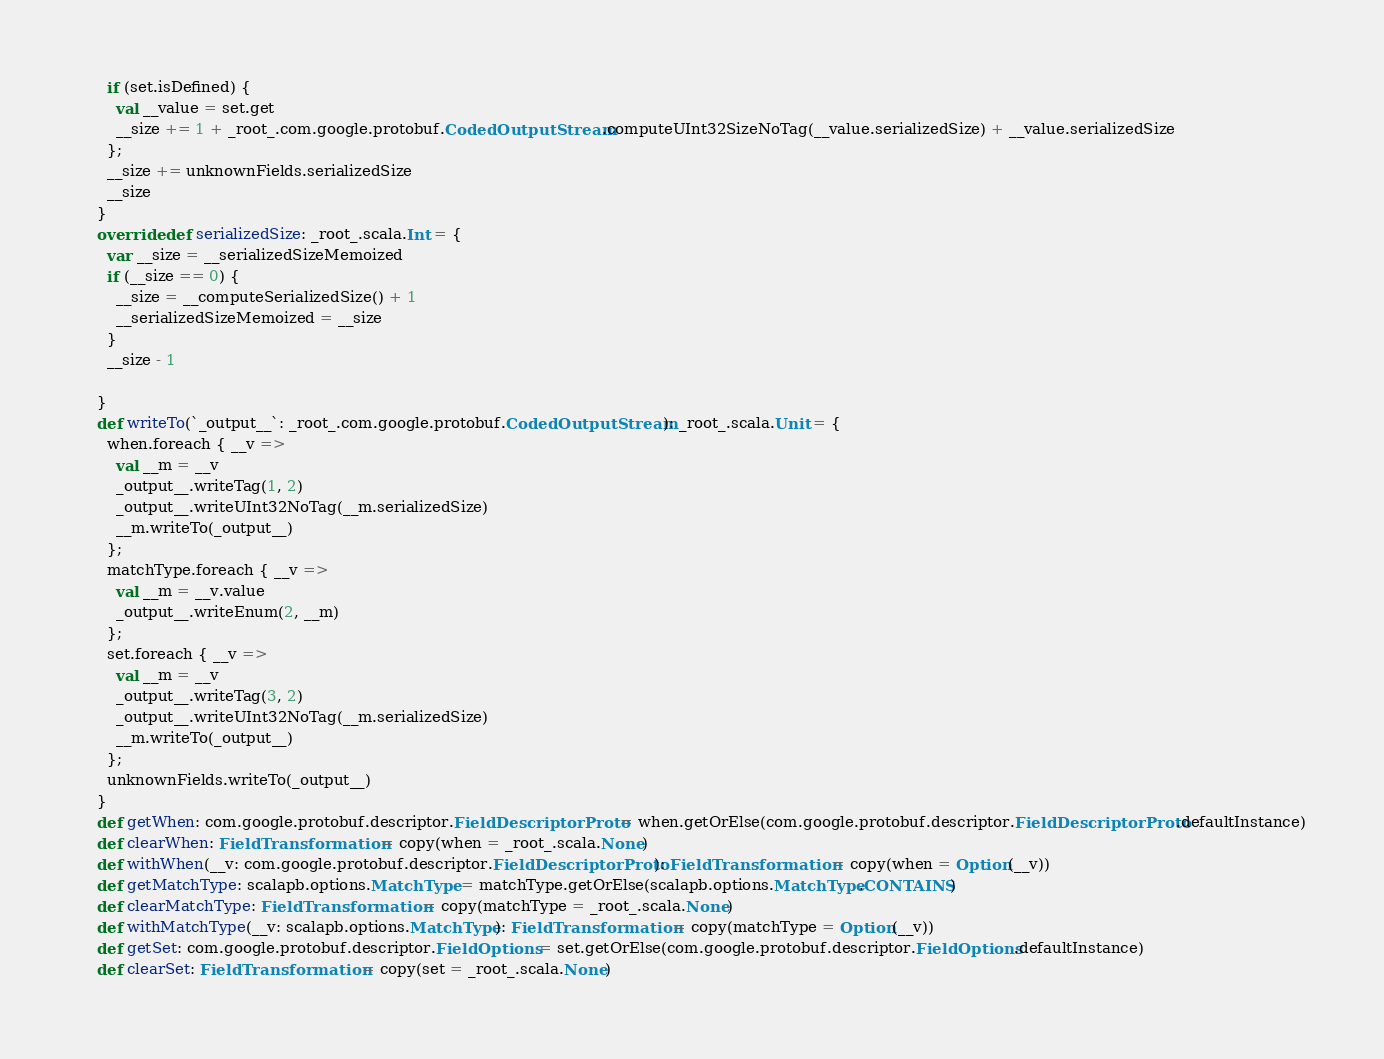Convert code to text. <code><loc_0><loc_0><loc_500><loc_500><_Scala_>      if (set.isDefined) {
        val __value = set.get
        __size += 1 + _root_.com.google.protobuf.CodedOutputStream.computeUInt32SizeNoTag(__value.serializedSize) + __value.serializedSize
      };
      __size += unknownFields.serializedSize
      __size
    }
    override def serializedSize: _root_.scala.Int = {
      var __size = __serializedSizeMemoized
      if (__size == 0) {
        __size = __computeSerializedSize() + 1
        __serializedSizeMemoized = __size
      }
      __size - 1
      
    }
    def writeTo(`_output__`: _root_.com.google.protobuf.CodedOutputStream): _root_.scala.Unit = {
      when.foreach { __v =>
        val __m = __v
        _output__.writeTag(1, 2)
        _output__.writeUInt32NoTag(__m.serializedSize)
        __m.writeTo(_output__)
      };
      matchType.foreach { __v =>
        val __m = __v.value
        _output__.writeEnum(2, __m)
      };
      set.foreach { __v =>
        val __m = __v
        _output__.writeTag(3, 2)
        _output__.writeUInt32NoTag(__m.serializedSize)
        __m.writeTo(_output__)
      };
      unknownFields.writeTo(_output__)
    }
    def getWhen: com.google.protobuf.descriptor.FieldDescriptorProto = when.getOrElse(com.google.protobuf.descriptor.FieldDescriptorProto.defaultInstance)
    def clearWhen: FieldTransformation = copy(when = _root_.scala.None)
    def withWhen(__v: com.google.protobuf.descriptor.FieldDescriptorProto): FieldTransformation = copy(when = Option(__v))
    def getMatchType: scalapb.options.MatchType = matchType.getOrElse(scalapb.options.MatchType.CONTAINS)
    def clearMatchType: FieldTransformation = copy(matchType = _root_.scala.None)
    def withMatchType(__v: scalapb.options.MatchType): FieldTransformation = copy(matchType = Option(__v))
    def getSet: com.google.protobuf.descriptor.FieldOptions = set.getOrElse(com.google.protobuf.descriptor.FieldOptions.defaultInstance)
    def clearSet: FieldTransformation = copy(set = _root_.scala.None)</code> 